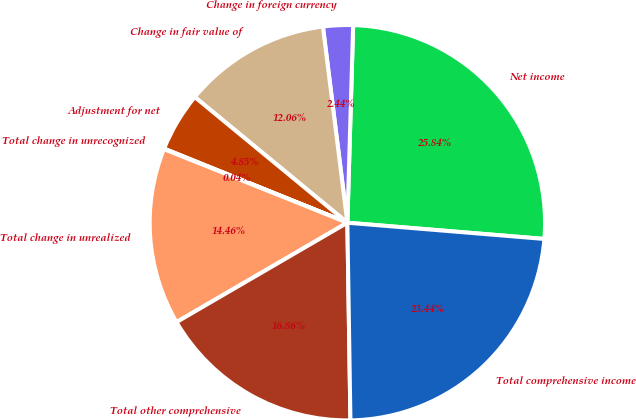Convert chart. <chart><loc_0><loc_0><loc_500><loc_500><pie_chart><fcel>Net income<fcel>Change in foreign currency<fcel>Change in fair value of<fcel>Adjustment for net<fcel>Total change in unrecognized<fcel>Total change in unrealized<fcel>Total other comprehensive<fcel>Total comprehensive income<nl><fcel>25.84%<fcel>2.44%<fcel>12.06%<fcel>4.85%<fcel>0.04%<fcel>14.46%<fcel>16.86%<fcel>23.44%<nl></chart> 